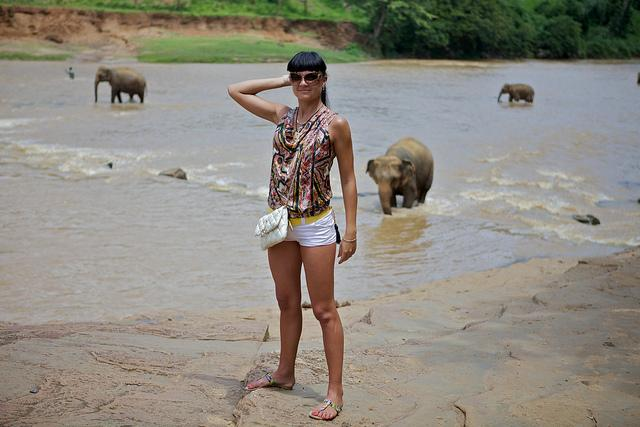Why is the woman holding her hand to her head? Please explain your reasoning. to pose. The woman is posing for the picture. 